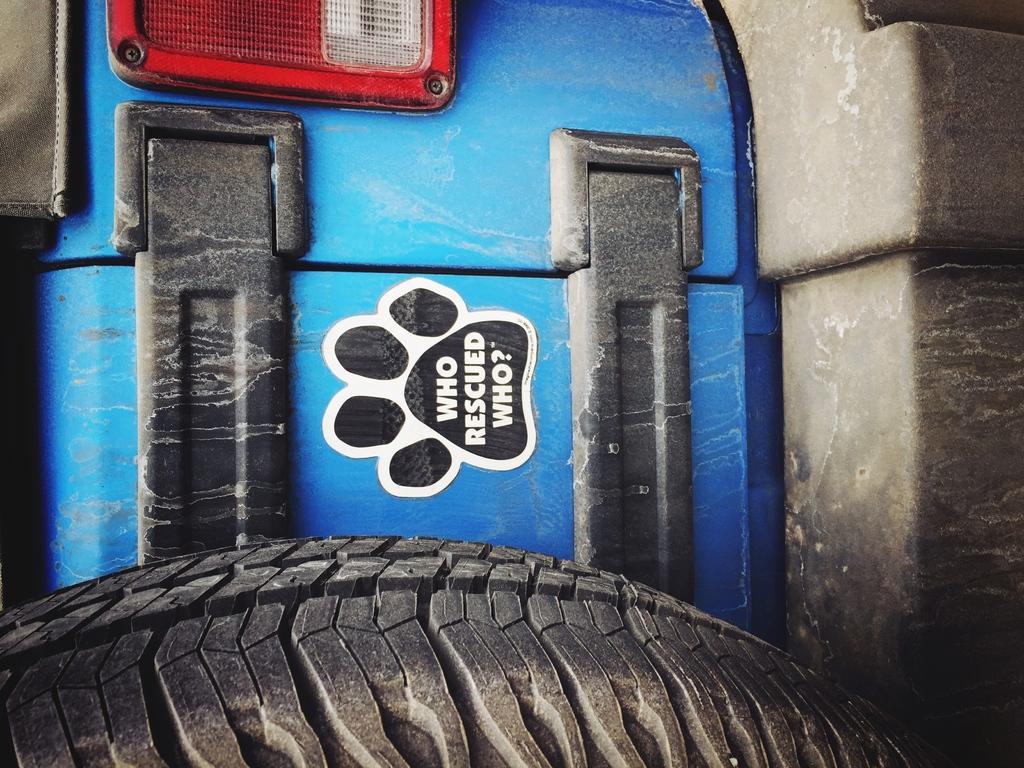Please provide a concise description of this image. In this picture, we see a vehicle in blue color. This picture contains one of the parts of the vehicle. At the bottom of the picture, we see a wheel or a tyre. At the top of the picture, we see a tail light. 